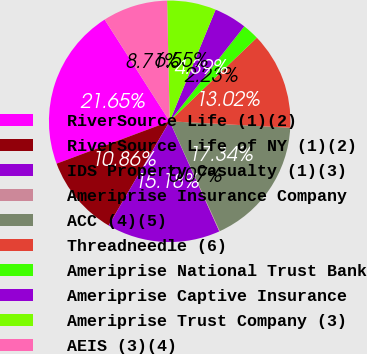Convert chart. <chart><loc_0><loc_0><loc_500><loc_500><pie_chart><fcel>RiverSource Life (1)(2)<fcel>RiverSource Life of NY (1)(2)<fcel>IDS Property Casualty (1)(3)<fcel>Ameriprise Insurance Company<fcel>ACC (4)(5)<fcel>Threadneedle (6)<fcel>Ameriprise National Trust Bank<fcel>Ameriprise Captive Insurance<fcel>Ameriprise Trust Company (3)<fcel>AEIS (3)(4)<nl><fcel>21.65%<fcel>10.86%<fcel>15.18%<fcel>0.07%<fcel>17.34%<fcel>13.02%<fcel>2.23%<fcel>4.39%<fcel>6.55%<fcel>8.71%<nl></chart> 